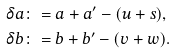<formula> <loc_0><loc_0><loc_500><loc_500>\delta a & \colon = a + a ^ { \prime } - ( u + s ) , \\ \delta b & \colon = b + b ^ { \prime } - ( v + w ) .</formula> 